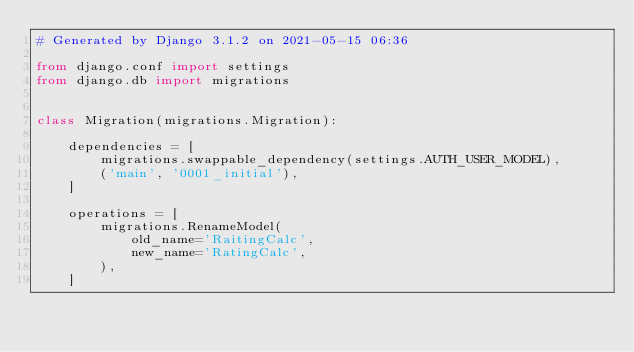<code> <loc_0><loc_0><loc_500><loc_500><_Python_># Generated by Django 3.1.2 on 2021-05-15 06:36

from django.conf import settings
from django.db import migrations


class Migration(migrations.Migration):

    dependencies = [
        migrations.swappable_dependency(settings.AUTH_USER_MODEL),
        ('main', '0001_initial'),
    ]

    operations = [
        migrations.RenameModel(
            old_name='RaitingCalc',
            new_name='RatingCalc',
        ),
    ]
</code> 